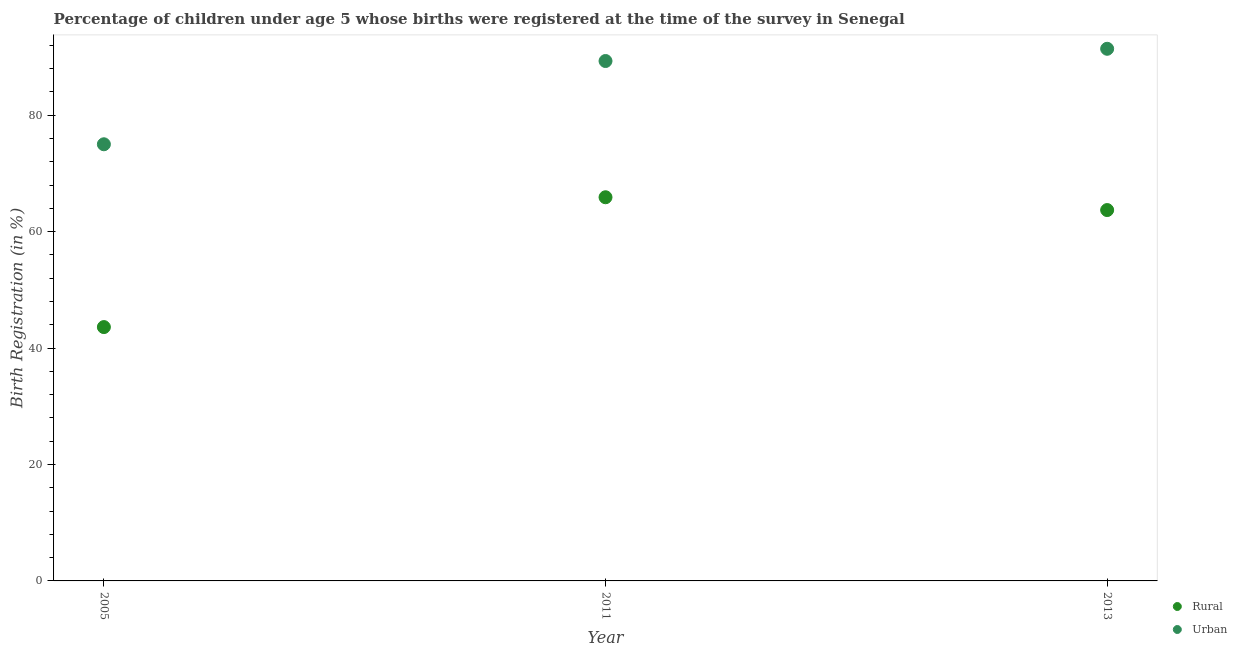What is the rural birth registration in 2011?
Your response must be concise. 65.9. Across all years, what is the maximum rural birth registration?
Provide a succinct answer. 65.9. In which year was the urban birth registration minimum?
Provide a short and direct response. 2005. What is the total rural birth registration in the graph?
Offer a terse response. 173.2. What is the difference between the urban birth registration in 2011 and that in 2013?
Make the answer very short. -2.1. What is the difference between the urban birth registration in 2011 and the rural birth registration in 2013?
Ensure brevity in your answer.  25.6. What is the average urban birth registration per year?
Your answer should be compact. 85.23. In the year 2011, what is the difference between the rural birth registration and urban birth registration?
Provide a succinct answer. -23.4. What is the ratio of the urban birth registration in 2005 to that in 2013?
Your response must be concise. 0.82. Is the rural birth registration in 2011 less than that in 2013?
Your answer should be compact. No. Is the difference between the urban birth registration in 2005 and 2011 greater than the difference between the rural birth registration in 2005 and 2011?
Your answer should be very brief. Yes. What is the difference between the highest and the second highest urban birth registration?
Provide a short and direct response. 2.1. What is the difference between the highest and the lowest rural birth registration?
Offer a terse response. 22.3. In how many years, is the urban birth registration greater than the average urban birth registration taken over all years?
Offer a terse response. 2. How many years are there in the graph?
Your answer should be compact. 3. Are the values on the major ticks of Y-axis written in scientific E-notation?
Keep it short and to the point. No. Does the graph contain any zero values?
Offer a terse response. No. Where does the legend appear in the graph?
Make the answer very short. Bottom right. How are the legend labels stacked?
Offer a very short reply. Vertical. What is the title of the graph?
Provide a succinct answer. Percentage of children under age 5 whose births were registered at the time of the survey in Senegal. Does "Savings" appear as one of the legend labels in the graph?
Keep it short and to the point. No. What is the label or title of the X-axis?
Ensure brevity in your answer.  Year. What is the label or title of the Y-axis?
Ensure brevity in your answer.  Birth Registration (in %). What is the Birth Registration (in %) of Rural in 2005?
Your answer should be compact. 43.6. What is the Birth Registration (in %) in Rural in 2011?
Your answer should be compact. 65.9. What is the Birth Registration (in %) of Urban in 2011?
Provide a short and direct response. 89.3. What is the Birth Registration (in %) in Rural in 2013?
Your answer should be compact. 63.7. What is the Birth Registration (in %) of Urban in 2013?
Provide a succinct answer. 91.4. Across all years, what is the maximum Birth Registration (in %) in Rural?
Offer a very short reply. 65.9. Across all years, what is the maximum Birth Registration (in %) in Urban?
Make the answer very short. 91.4. Across all years, what is the minimum Birth Registration (in %) of Rural?
Give a very brief answer. 43.6. What is the total Birth Registration (in %) of Rural in the graph?
Provide a succinct answer. 173.2. What is the total Birth Registration (in %) of Urban in the graph?
Provide a succinct answer. 255.7. What is the difference between the Birth Registration (in %) of Rural in 2005 and that in 2011?
Ensure brevity in your answer.  -22.3. What is the difference between the Birth Registration (in %) of Urban in 2005 and that in 2011?
Provide a short and direct response. -14.3. What is the difference between the Birth Registration (in %) in Rural in 2005 and that in 2013?
Your response must be concise. -20.1. What is the difference between the Birth Registration (in %) of Urban in 2005 and that in 2013?
Offer a terse response. -16.4. What is the difference between the Birth Registration (in %) in Urban in 2011 and that in 2013?
Give a very brief answer. -2.1. What is the difference between the Birth Registration (in %) in Rural in 2005 and the Birth Registration (in %) in Urban in 2011?
Keep it short and to the point. -45.7. What is the difference between the Birth Registration (in %) in Rural in 2005 and the Birth Registration (in %) in Urban in 2013?
Your answer should be compact. -47.8. What is the difference between the Birth Registration (in %) in Rural in 2011 and the Birth Registration (in %) in Urban in 2013?
Give a very brief answer. -25.5. What is the average Birth Registration (in %) in Rural per year?
Your response must be concise. 57.73. What is the average Birth Registration (in %) in Urban per year?
Provide a short and direct response. 85.23. In the year 2005, what is the difference between the Birth Registration (in %) of Rural and Birth Registration (in %) of Urban?
Ensure brevity in your answer.  -31.4. In the year 2011, what is the difference between the Birth Registration (in %) in Rural and Birth Registration (in %) in Urban?
Offer a very short reply. -23.4. In the year 2013, what is the difference between the Birth Registration (in %) in Rural and Birth Registration (in %) in Urban?
Ensure brevity in your answer.  -27.7. What is the ratio of the Birth Registration (in %) in Rural in 2005 to that in 2011?
Ensure brevity in your answer.  0.66. What is the ratio of the Birth Registration (in %) in Urban in 2005 to that in 2011?
Your answer should be compact. 0.84. What is the ratio of the Birth Registration (in %) in Rural in 2005 to that in 2013?
Your response must be concise. 0.68. What is the ratio of the Birth Registration (in %) in Urban in 2005 to that in 2013?
Give a very brief answer. 0.82. What is the ratio of the Birth Registration (in %) in Rural in 2011 to that in 2013?
Offer a terse response. 1.03. What is the ratio of the Birth Registration (in %) of Urban in 2011 to that in 2013?
Your response must be concise. 0.98. What is the difference between the highest and the second highest Birth Registration (in %) in Rural?
Offer a very short reply. 2.2. What is the difference between the highest and the lowest Birth Registration (in %) in Rural?
Ensure brevity in your answer.  22.3. 